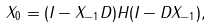Convert formula to latex. <formula><loc_0><loc_0><loc_500><loc_500>X _ { 0 } = ( I - X _ { - 1 } D ) H ( I - D X _ { - 1 } ) ,</formula> 